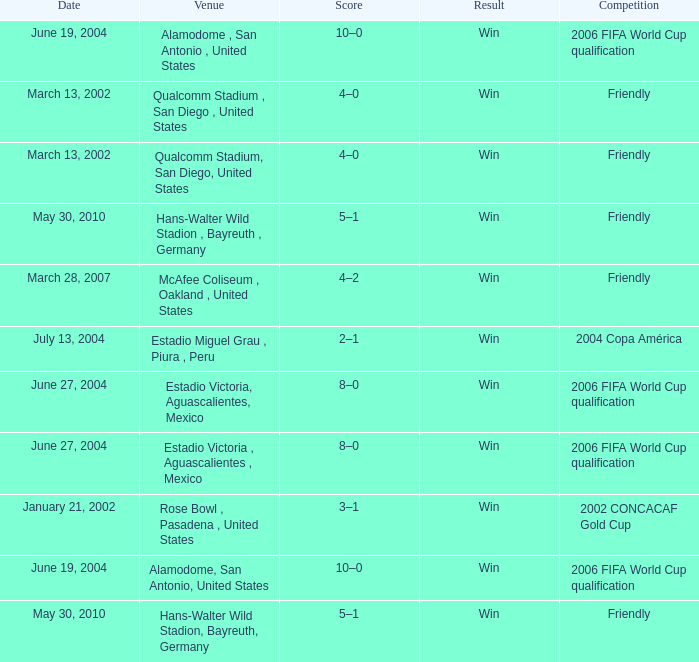On which date was the 2006 fifa world cup qualification held at alamodome, san antonio, united states? June 19, 2004, June 19, 2004. 